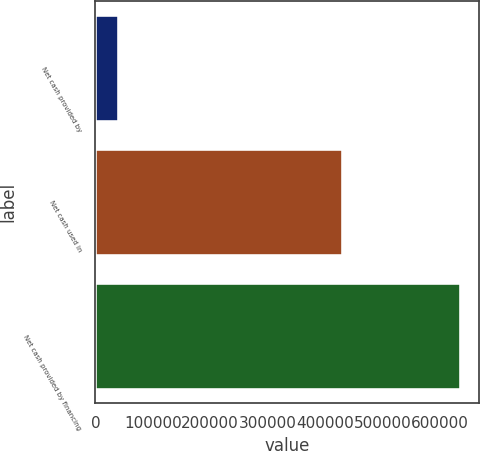Convert chart. <chart><loc_0><loc_0><loc_500><loc_500><bar_chart><fcel>Net cash provided by<fcel>Net cash used in<fcel>Net cash provided by financing<nl><fcel>40883<fcel>430796<fcel>636343<nl></chart> 